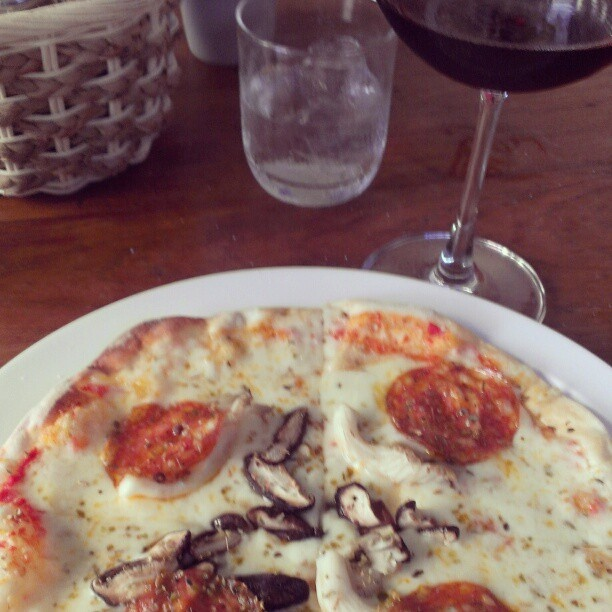Describe the objects in this image and their specific colors. I can see dining table in maroon, gray, darkgray, black, and brown tones, pizza in gray, brown, tan, and beige tones, cup in gray, purple, and black tones, wine glass in gray, black, and purple tones, and cup in gray, purple, and black tones in this image. 